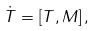<formula> <loc_0><loc_0><loc_500><loc_500>\dot { T } = \left [ T , M \right ] ,</formula> 